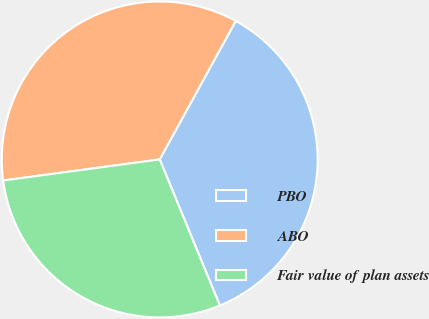Convert chart to OTSL. <chart><loc_0><loc_0><loc_500><loc_500><pie_chart><fcel>PBO<fcel>ABO<fcel>Fair value of plan assets<nl><fcel>35.79%<fcel>35.12%<fcel>29.09%<nl></chart> 